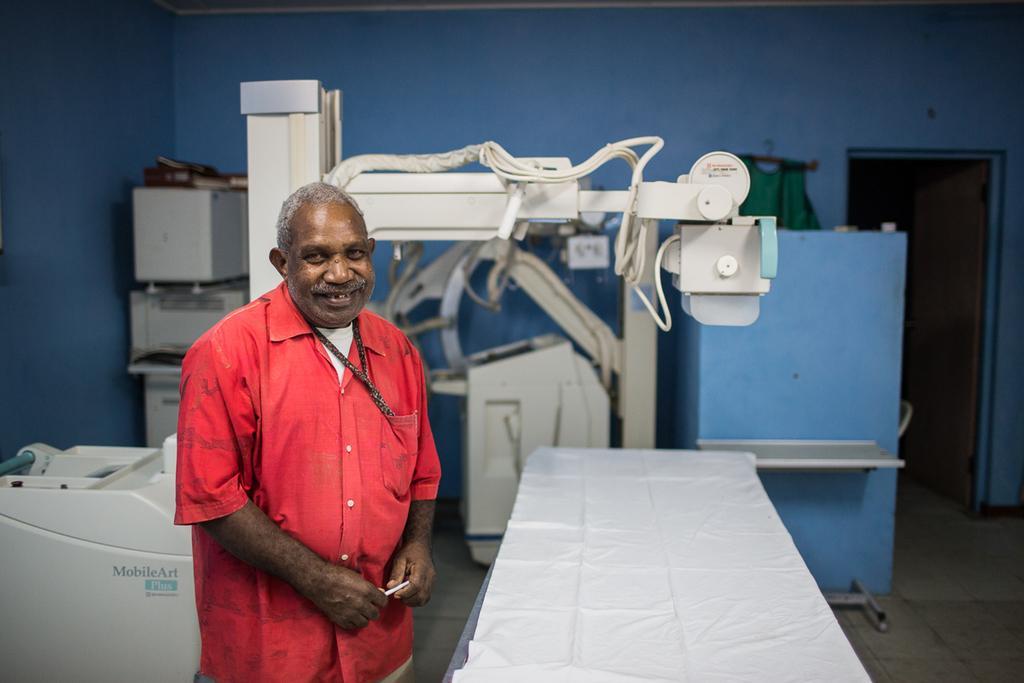In one or two sentences, can you explain what this image depicts? In this picture, we can see a person, and the ground with some objects like machines, table covered with white cloth, and we can see the wall with door, and some object attached to it. 